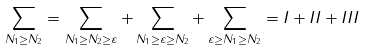Convert formula to latex. <formula><loc_0><loc_0><loc_500><loc_500>\sum _ { N _ { 1 } \geq N _ { 2 } } = \sum _ { N _ { 1 } \geq N _ { 2 } \geq \varepsilon } + \sum _ { N _ { 1 } \geq \varepsilon \geq N _ { 2 } } + \sum _ { \varepsilon \geq N _ { 1 } \geq N _ { 2 } } = I + I I + I I I</formula> 